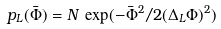<formula> <loc_0><loc_0><loc_500><loc_500>p _ { L } ( { \bar { \Phi } } ) = N \, \exp ( - { \bar { \Phi } } ^ { 2 } / 2 ( \Delta _ { L } \Phi ) ^ { 2 } )</formula> 